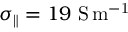Convert formula to latex. <formula><loc_0><loc_0><loc_500><loc_500>\sigma _ { \| } = 1 9 \ S \, m ^ { - 1 }</formula> 